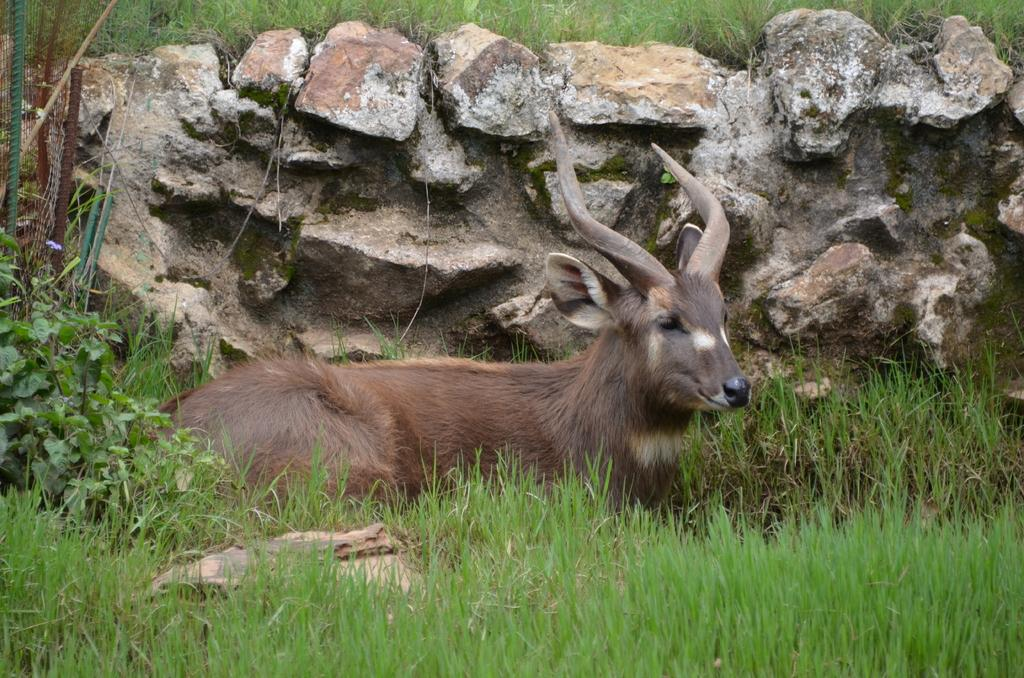What type of animal is on the ground in the image? The specific type of animal cannot be determined from the image. What other elements are present in the image besides the animal? There are plants, rods, grass, and a wall in the image. Can you describe the plants in the image? The plants in the image cannot be identified in detail, but they are present. What is the ground made of in the image? The ground in the image is made of grass. What is the wall made of in the image? The material of the wall cannot be determined from the image. What type of game is being played on the wall in the image? There is no game being played on the wall in the image. 